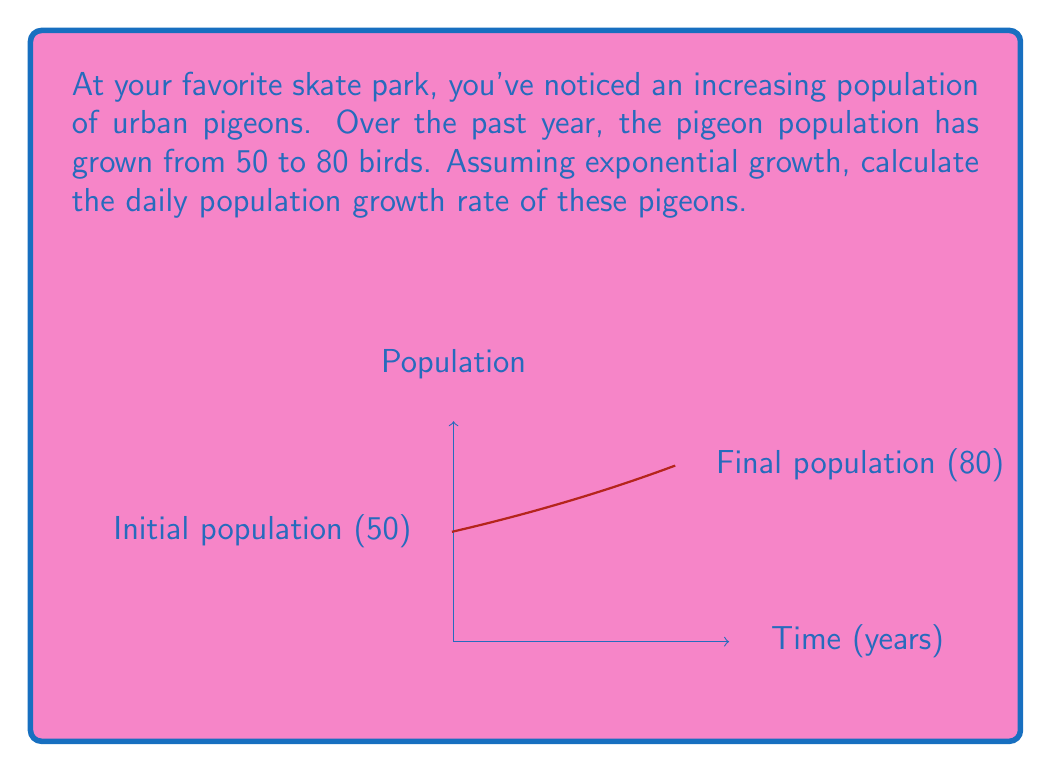Teach me how to tackle this problem. To solve this problem, we'll use the exponential growth model:

$$N(t) = N_0 \cdot e^{rt}$$

Where:
$N(t)$ is the population at time $t$
$N_0$ is the initial population
$r$ is the growth rate
$t$ is the time period

Given:
$N_0 = 50$ (initial population)
$N(1) = 80$ (population after 1 year)
$t = 1$ year

Step 1: Plug the values into the exponential growth equation:
$$80 = 50 \cdot e^{r \cdot 1}$$

Step 2: Simplify:
$$80 = 50 \cdot e^r$$

Step 3: Divide both sides by 50:
$$\frac{80}{50} = e^r$$

Step 4: Take the natural log of both sides:
$$\ln(\frac{80}{50}) = \ln(e^r) = r$$

Step 5: Calculate r:
$$r = \ln(1.6) \approx 0.4700$$

This is the yearly growth rate. To find the daily rate, divide by 365:

$$r_{daily} = \frac{0.4700}{365} \approx 0.001288$$

Step 6: Convert to percentage:
$$r_{daily} \approx 0.001288 \cdot 100\% = 0.1288\%$$
Answer: 0.1288% per day 